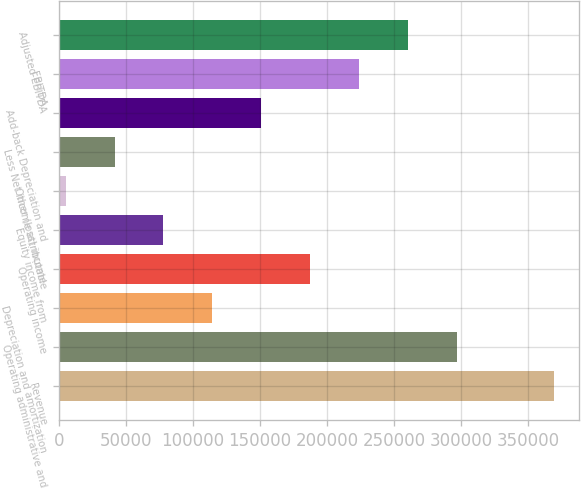Convert chart. <chart><loc_0><loc_0><loc_500><loc_500><bar_chart><fcel>Revenue<fcel>Operating administrative and<fcel>Depreciation and amortization<fcel>Operating income<fcel>Equity income from<fcel>Other (loss) income<fcel>Less Net income attributable<fcel>Add-back Depreciation and<fcel>EBITDA<fcel>Adjusted EBITDA<nl><fcel>369800<fcel>297194<fcel>114269<fcel>187278<fcel>77764.8<fcel>4756<fcel>41260.4<fcel>150774<fcel>223782<fcel>260287<nl></chart> 